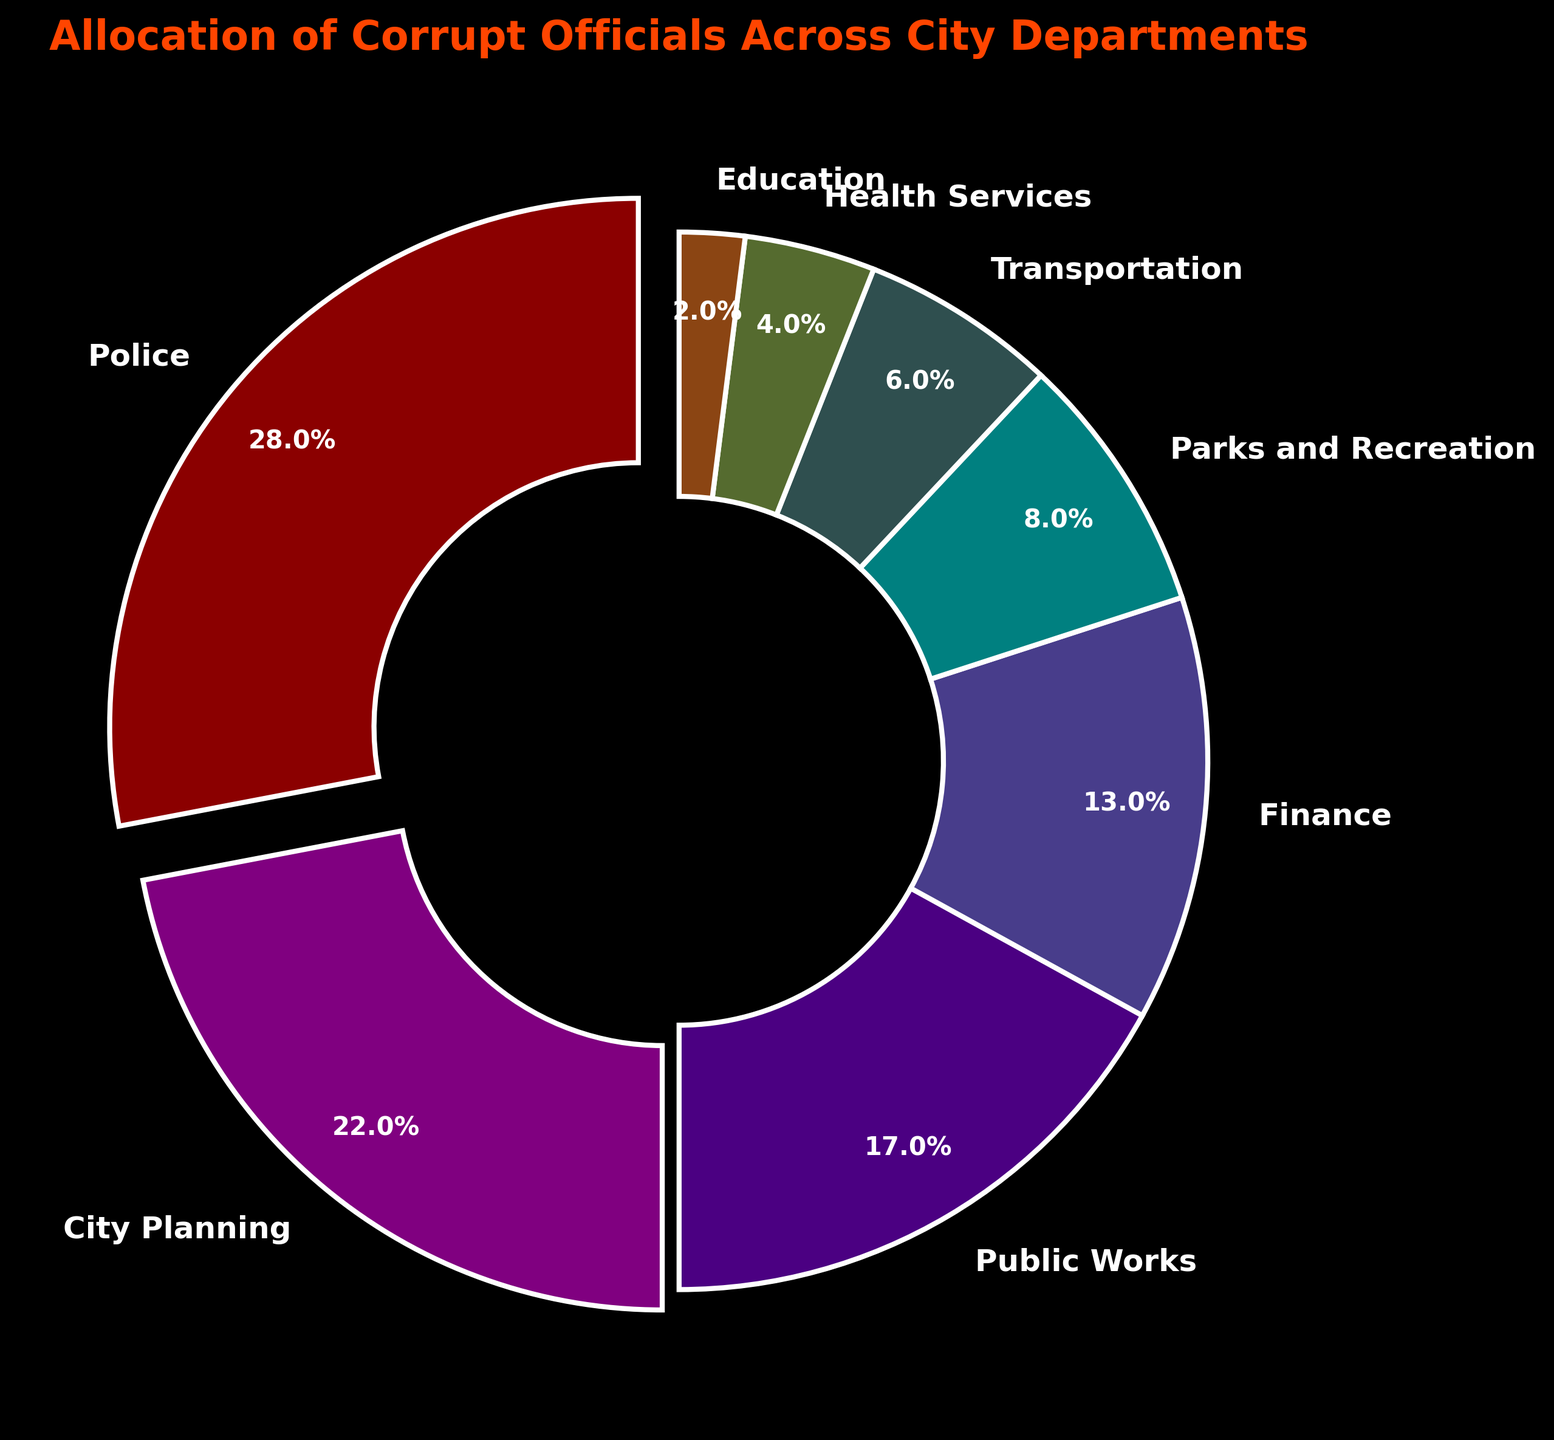Which department has the highest percentage of corrupt officials? The pie chart shows the allocation of corrupt officials across different city departments, with Police having the largest slice.
Answer: Police Which departments have a higher percentage of corrupt officials than the Finance department? Look at the percentages for each department and compare them to the Finance department's 13%. The departments with higher percentages are Police, City Planning, and Public Works.
Answer: Police, City Planning, Public Works How do the percentages of Parks and Recreation and Transportation compare? Parks and Recreation is 8%, and Transportation is 6%. Parks and Recreation has a higher percentage than Transportation.
Answer: Parks and Recreation What is the combined percentage of corrupt officials in Public Works and Health Services? Add the percentages for Public Works (17%) and Health Services (4%). The total is 17% + 4% = 21%.
Answer: 21% Which department has the smallest allocation of corrupt officials? Identify the department with the smallest percentage slice in the pie chart, which is Education at 2%.
Answer: Education What is the difference in percentage points between City Planning and Parks and Recreation? Subtract the percentage for Parks and Recreation (8%) from City Planning (22%). The difference is 22% - 8% = 14%.
Answer: 14% Which department pairs have a combined total of 30% or more? Identify pairs of departments whose percentages add up to 30% or above: Police (28%) and any other department won't make 30%. City Planning (22%) + Public Works (17%) = 39%. There are no other pairs that meet this criterion.
Answer: City Planning and Public Works What fraction of the total allocation is accounted for by Finance and Transportation combined? Add the percentages of Finance (13%) and Transportation (6%). The total is 13% + 6% = 19%. Since the whole pie represents 100%, the fraction is 19/100.
Answer: 19/100 